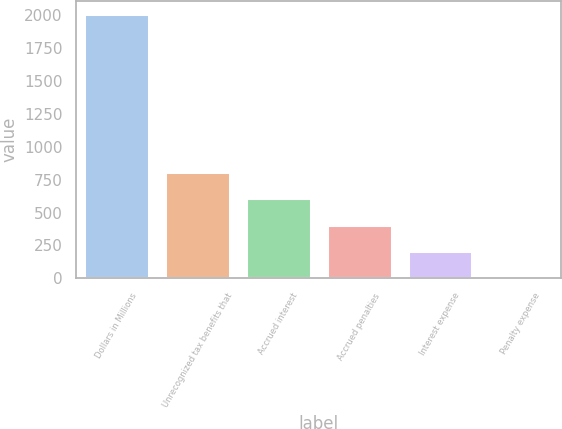<chart> <loc_0><loc_0><loc_500><loc_500><bar_chart><fcel>Dollars in Millions<fcel>Unrecognized tax benefits that<fcel>Accrued interest<fcel>Accrued penalties<fcel>Interest expense<fcel>Penalty expense<nl><fcel>2011<fcel>808.6<fcel>608.2<fcel>407.8<fcel>207.4<fcel>7<nl></chart> 